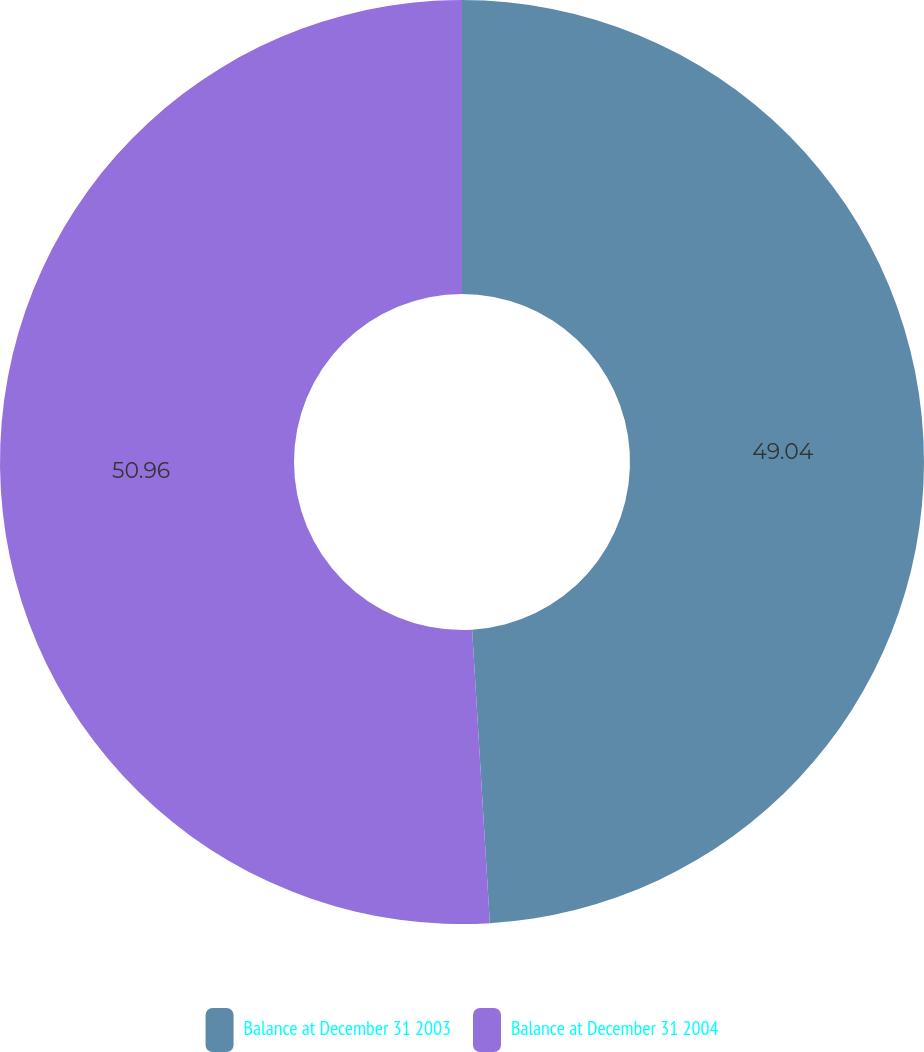Convert chart. <chart><loc_0><loc_0><loc_500><loc_500><pie_chart><fcel>Balance at December 31 2003<fcel>Balance at December 31 2004<nl><fcel>49.04%<fcel>50.96%<nl></chart> 